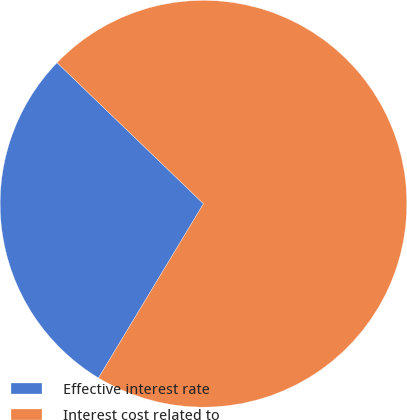<chart> <loc_0><loc_0><loc_500><loc_500><pie_chart><fcel>Effective interest rate<fcel>Interest cost related to<nl><fcel>28.57%<fcel>71.43%<nl></chart> 